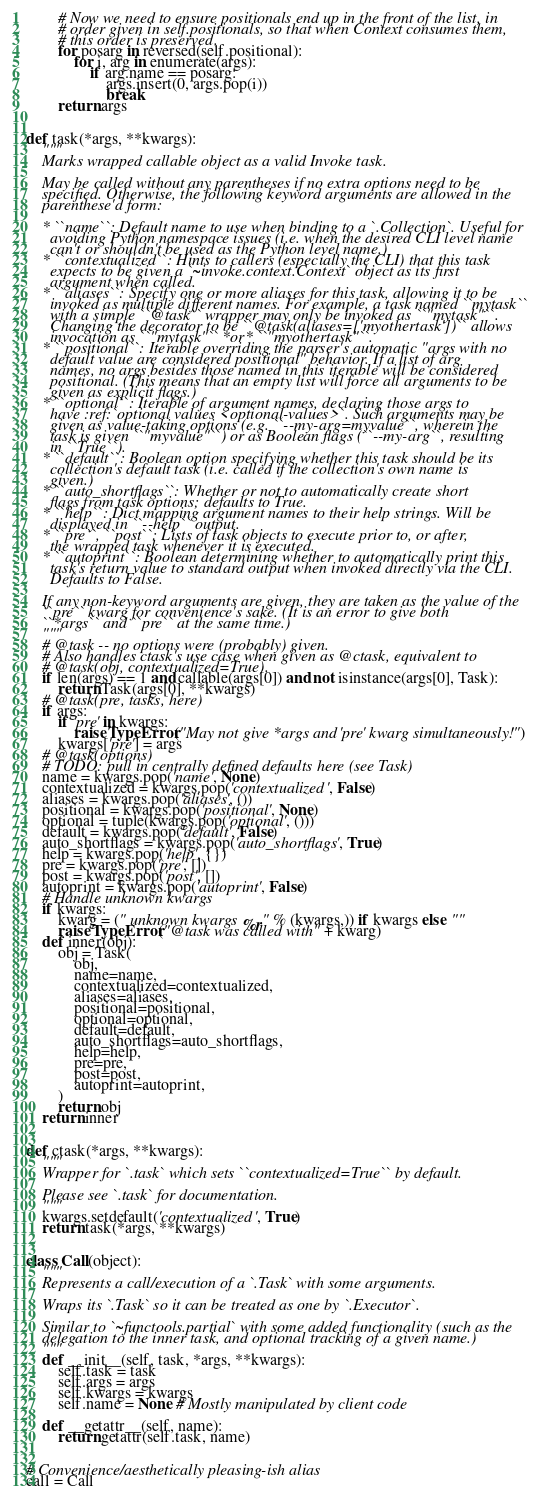Convert code to text. <code><loc_0><loc_0><loc_500><loc_500><_Python_>        # Now we need to ensure positionals end up in the front of the list, in
        # order given in self.positionals, so that when Context consumes them,
        # this order is preserved.
        for posarg in reversed(self.positional):
            for i, arg in enumerate(args):
                if arg.name == posarg:
                    args.insert(0, args.pop(i))
                    break
        return args


def task(*args, **kwargs):
    """
    Marks wrapped callable object as a valid Invoke task.

    May be called without any parentheses if no extra options need to be
    specified. Otherwise, the following keyword arguments are allowed in the
    parenthese'd form:

    * ``name``: Default name to use when binding to a `.Collection`. Useful for
      avoiding Python namespace issues (i.e. when the desired CLI level name
      can't or shouldn't be used as the Python level name.)
    * ``contextualized``: Hints to callers (especially the CLI) that this task
      expects to be given a `~invoke.context.Context` object as its first
      argument when called.
    * ``aliases``: Specify one or more aliases for this task, allowing it to be
      invoked as multiple different names. For example, a task named ``mytask``
      with a simple ``@task`` wrapper may only be invoked as ``"mytask"``.
      Changing the decorator to be ``@task(aliases=['myothertask'])`` allows
      invocation as ``"mytask"`` *or* ``"myothertask"``.
    * ``positional``: Iterable overriding the parser's automatic "args with no
      default value are considered positional" behavior. If a list of arg
      names, no args besides those named in this iterable will be considered
      positional. (This means that an empty list will force all arguments to be
      given as explicit flags.)
    * ``optional``: Iterable of argument names, declaring those args to
      have :ref:`optional values <optional-values>`. Such arguments may be
      given as value-taking options (e.g. ``--my-arg=myvalue``, wherein the
      task is given ``"myvalue"``) or as Boolean flags (``--my-arg``, resulting
      in ``True``).
    * ``default``: Boolean option specifying whether this task should be its
      collection's default task (i.e. called if the collection's own name is
      given.)
    * ``auto_shortflags``: Whether or not to automatically create short
      flags from task options; defaults to True.
    * ``help``: Dict mapping argument names to their help strings. Will be
      displayed in ``--help`` output.
    * ``pre``, ``post``: Lists of task objects to execute prior to, or after,
      the wrapped task whenever it is executed.
    * ``autoprint``: Boolean determining whether to automatically print this
      task's return value to standard output when invoked directly via the CLI.
      Defaults to False.

    If any non-keyword arguments are given, they are taken as the value of the
    ``pre`` kwarg for convenience's sake. (It is an error to give both
    ``*args`` and ``pre`` at the same time.)
    """
    # @task -- no options were (probably) given.
    # Also handles ctask's use case when given as @ctask, equivalent to
    # @task(obj, contextualized=True).
    if len(args) == 1 and callable(args[0]) and not isinstance(args[0], Task):
        return Task(args[0], **kwargs)
    # @task(pre, tasks, here)
    if args:
        if 'pre' in kwargs:
            raise TypeError("May not give *args and 'pre' kwarg simultaneously!")
        kwargs['pre'] = args
    # @task(options)
    # TODO: pull in centrally defined defaults here (see Task)
    name = kwargs.pop('name', None)
    contextualized = kwargs.pop('contextualized', False)
    aliases = kwargs.pop('aliases', ())
    positional = kwargs.pop('positional', None)
    optional = tuple(kwargs.pop('optional', ()))
    default = kwargs.pop('default', False)
    auto_shortflags = kwargs.pop('auto_shortflags', True)
    help = kwargs.pop('help', {})
    pre = kwargs.pop('pre', [])
    post = kwargs.pop('post', [])
    autoprint = kwargs.pop('autoprint', False)
    # Handle unknown kwargs
    if kwargs:
        kwarg = (" unknown kwargs %r" % (kwargs,)) if kwargs else ""
        raise TypeError("@task was called with" + kwarg)
    def inner(obj):
        obj = Task(
            obj,
            name=name,
            contextualized=contextualized,
            aliases=aliases,
            positional=positional,
            optional=optional,
            default=default,
            auto_shortflags=auto_shortflags,
            help=help,
            pre=pre,
            post=post,
            autoprint=autoprint,
        )
        return obj
    return inner


def ctask(*args, **kwargs):
    """
    Wrapper for `.task` which sets ``contextualized=True`` by default.

    Please see `.task` for documentation.
    """
    kwargs.setdefault('contextualized', True)
    return task(*args, **kwargs)


class Call(object):
    """
    Represents a call/execution of a `.Task` with some arguments.

    Wraps its `.Task` so it can be treated as one by `.Executor`.

    Similar to `~functools.partial` with some added functionality (such as the
    delegation to the inner task, and optional tracking of a given name.)
    """
    def __init__(self, task, *args, **kwargs):
        self.task = task
        self.args = args
        self.kwargs = kwargs
        self.name = None # Mostly manipulated by client code

    def __getattr__(self, name):
        return getattr(self.task, name)


# Convenience/aesthetically pleasing-ish alias
call = Call
</code> 